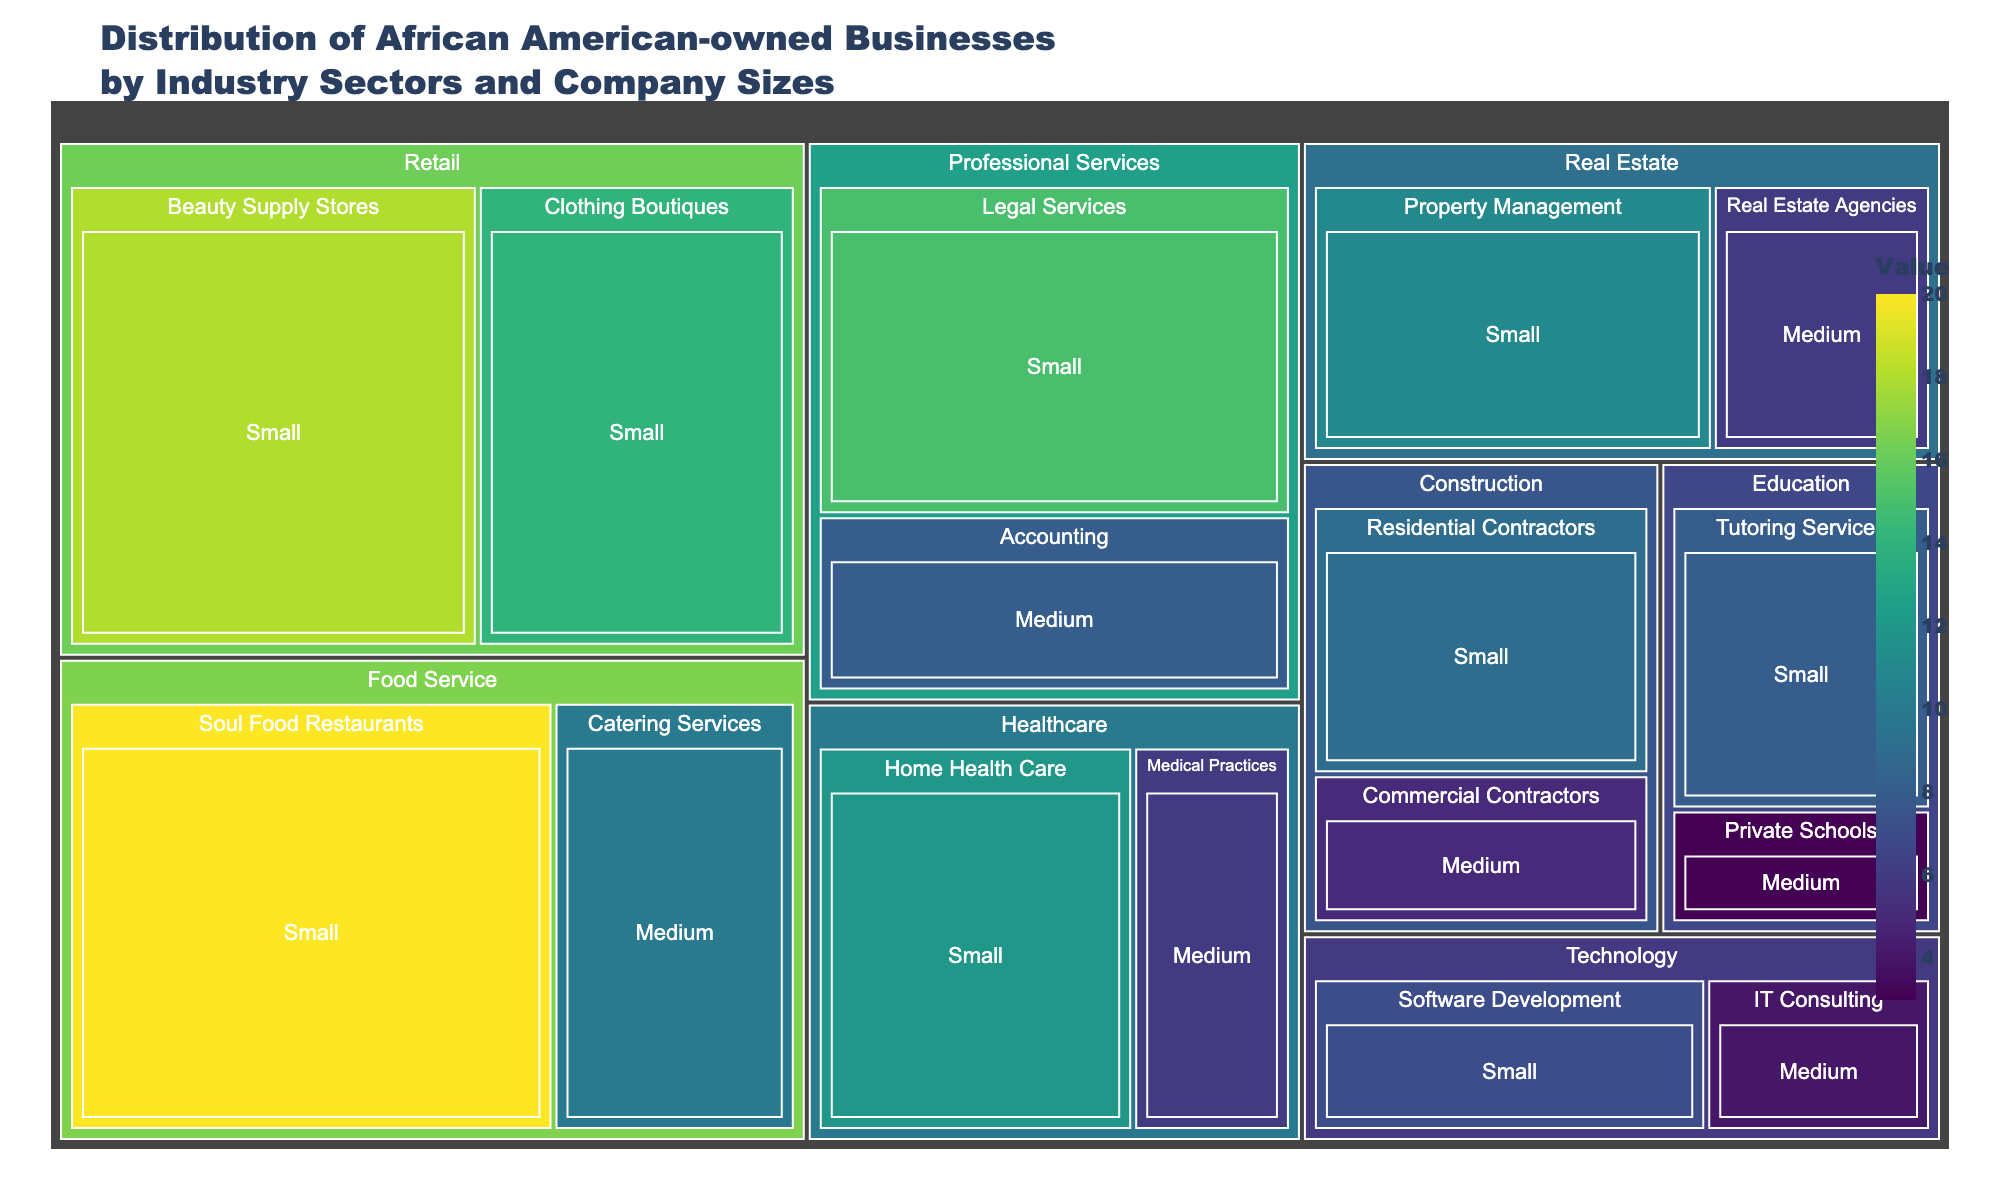What's the title of the treemap? The title of the treemap is usually displayed at the top of the figure. In this case, it should be "Distribution of African American-owned Businesses by Industry Sectors and Company Sizes".
Answer: Distribution of African American-owned Businesses by Industry Sectors and Company Sizes Which sector has the highest value in the Food Service industry? To find the sector with the highest value in the Food Service industry, we compare the values of the sectors under Food Service: Soul Food Restaurants (20) and Catering Services (10). Soul Food Restaurants has the higher value.
Answer: Soul Food Restaurants How many small-sized businesses are there in the Healthcare industry? Adding up the values of small-sized businesses in Healthcare, we have Home Health Care (12).
Answer: 12 What is the total value of medium-sized businesses in the Professional Services industry? Summing up the values of medium-sized businesses in Professional Services, we have Accounting (8).
Answer: 8 Which industry has more small-sized businesses, Construction or Technology? Comparing the values of small-sized businesses in Construction (Residential Contractors, 9) and Technology (Software Development, 7), Construction has more small-sized businesses.
Answer: Construction What's the average value of businesses in the Retail industry? There are two sectors in Retail: Beauty Supply Stores (18) and Clothing Boutiques (14). Add them up to get 32 and then divide by the number of sectors, 2. So, 32/2 = 16.
Answer: 16 Which sector in Professional Services has the larger value for small-sized businesses? Comparing the values of small-sized businesses in Professional Services: Legal Services (15) and Accounting (Medium, hence not considered), Legal Services has the larger value.
Answer: Legal Services What is the total value of businesses in the Technology industry? Summing up small-sized and medium-sized businesses in Technology, we get Software Development (7) + IT Consulting (4) = 11.
Answer: 11 Which industry has the least value for medium-sized businesses? By comparing the values of medium-sized businesses across all industries, Private Schools in Education has the lowest value (3).
Answer: Education 